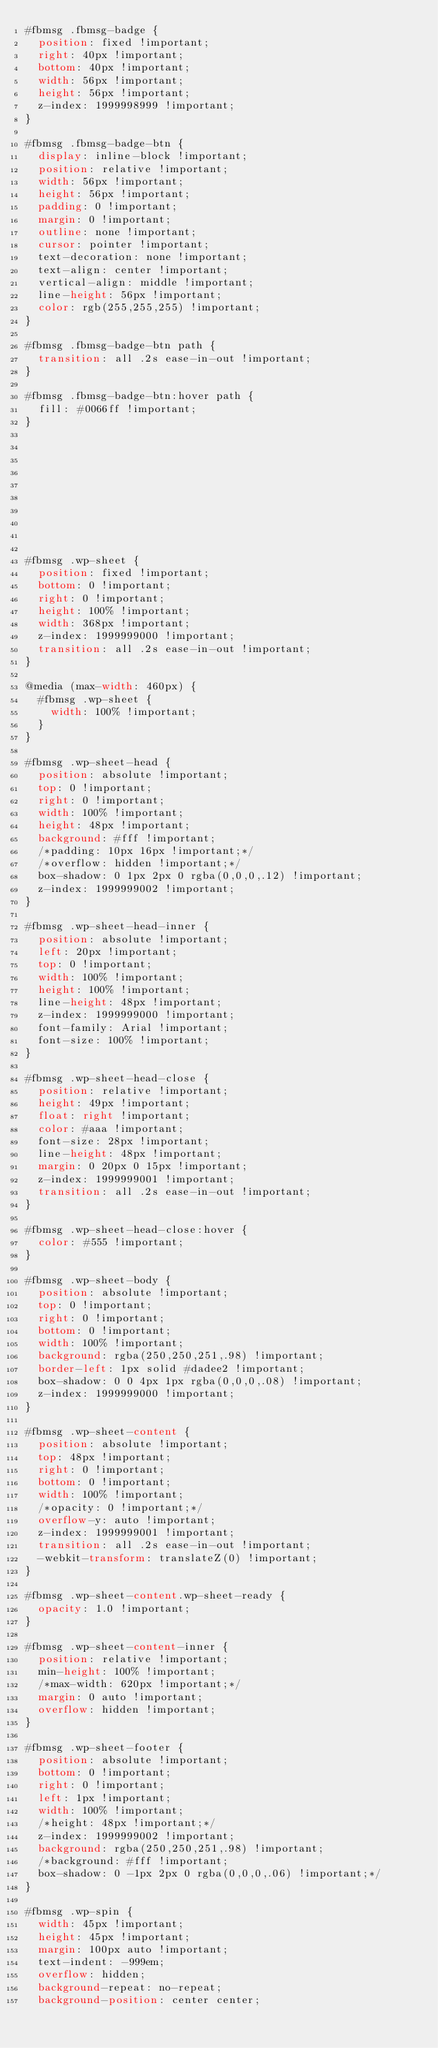<code> <loc_0><loc_0><loc_500><loc_500><_CSS_>#fbmsg .fbmsg-badge {
  position: fixed !important;
  right: 40px !important;
  bottom: 40px !important;
  width: 56px !important;
  height: 56px !important;
  z-index: 1999998999 !important;
}

#fbmsg .fbmsg-badge-btn {
  display: inline-block !important;
  position: relative !important;
  width: 56px !important;
  height: 56px !important;
  padding: 0 !important;
  margin: 0 !important;
  outline: none !important;
  cursor: pointer !important;
  text-decoration: none !important;
  text-align: center !important;
  vertical-align: middle !important;
  line-height: 56px !important;
  color: rgb(255,255,255) !important;
}

#fbmsg .fbmsg-badge-btn path {
  transition: all .2s ease-in-out !important;
}

#fbmsg .fbmsg-badge-btn:hover path {
  fill: #0066ff !important;
}










#fbmsg .wp-sheet {
  position: fixed !important;
  bottom: 0 !important;
  right: 0 !important;
  height: 100% !important;
  width: 368px !important;
  z-index: 1999999000 !important;
  transition: all .2s ease-in-out !important;
}

@media (max-width: 460px) {
  #fbmsg .wp-sheet {
    width: 100% !important;
  }
}

#fbmsg .wp-sheet-head {
  position: absolute !important;
  top: 0 !important;
  right: 0 !important;
  width: 100% !important;
  height: 48px !important;
  background: #fff !important;
  /*padding: 10px 16px !important;*/
  /*overflow: hidden !important;*/
  box-shadow: 0 1px 2px 0 rgba(0,0,0,.12) !important;
  z-index: 1999999002 !important;
}

#fbmsg .wp-sheet-head-inner {
  position: absolute !important;
  left: 20px !important;
  top: 0 !important;
  width: 100% !important;
  height: 100% !important;
  line-height: 48px !important;
  z-index: 1999999000 !important;
  font-family: Arial !important;
  font-size: 100% !important;
}

#fbmsg .wp-sheet-head-close {
  position: relative !important;
  height: 49px !important;
  float: right !important;
  color: #aaa !important;
  font-size: 28px !important;
  line-height: 48px !important;
  margin: 0 20px 0 15px !important;
  z-index: 1999999001 !important;
  transition: all .2s ease-in-out !important;
}

#fbmsg .wp-sheet-head-close:hover {
  color: #555 !important;
}

#fbmsg .wp-sheet-body {
  position: absolute !important;
  top: 0 !important;
  right: 0 !important;
  bottom: 0 !important;
  width: 100% !important;
  background: rgba(250,250,251,.98) !important;
  border-left: 1px solid #dadee2 !important;
  box-shadow: 0 0 4px 1px rgba(0,0,0,.08) !important;
  z-index: 1999999000 !important;
}

#fbmsg .wp-sheet-content {
  position: absolute !important;
  top: 48px !important;
  right: 0 !important;
  bottom: 0 !important;
  width: 100% !important;
  /*opacity: 0 !important;*/
  overflow-y: auto !important;
  z-index: 1999999001 !important;
  transition: all .2s ease-in-out !important;
  -webkit-transform: translateZ(0) !important;
}

#fbmsg .wp-sheet-content.wp-sheet-ready {
  opacity: 1.0 !important;
}

#fbmsg .wp-sheet-content-inner {
  position: relative !important;
  min-height: 100% !important;
  /*max-width: 620px !important;*/
  margin: 0 auto !important;
  overflow: hidden !important;
}

#fbmsg .wp-sheet-footer {
  position: absolute !important;
  bottom: 0 !important;
  right: 0 !important;
  left: 1px !important;
  width: 100% !important;
  /*height: 48px !important;*/
  z-index: 1999999002 !important;
  background: rgba(250,250,251,.98) !important;
  /*background: #fff !important;
  box-shadow: 0 -1px 2px 0 rgba(0,0,0,.06) !important;*/
}

#fbmsg .wp-spin {
  width: 45px !important;
  height: 45px !important;
  margin: 100px auto !important;
  text-indent: -999em;
  overflow: hidden;
  background-repeat: no-repeat;
  background-position: center center;</code> 